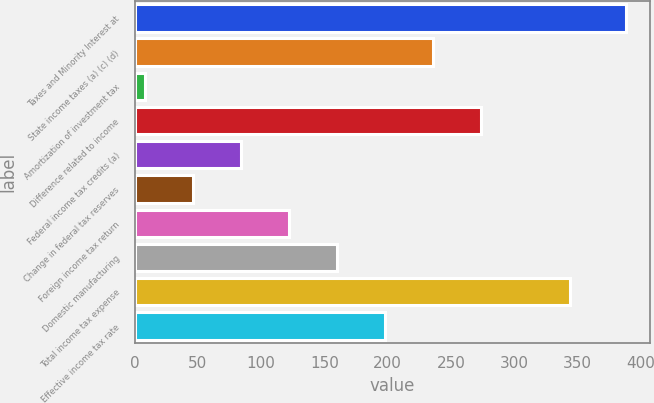Convert chart to OTSL. <chart><loc_0><loc_0><loc_500><loc_500><bar_chart><fcel>Taxes and Minority Interest at<fcel>State income taxes (a) (c) (d)<fcel>Amortization of investment tax<fcel>Difference related to income<fcel>Federal income tax credits (a)<fcel>Change in federal tax reserves<fcel>Foreign income tax return<fcel>Domestic manufacturing<fcel>Total income tax expense<fcel>Effective income tax rate<nl><fcel>388<fcel>236<fcel>8<fcel>274<fcel>84<fcel>46<fcel>122<fcel>160<fcel>344<fcel>198<nl></chart> 